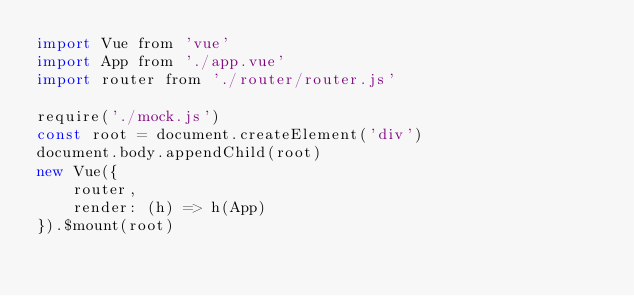<code> <loc_0><loc_0><loc_500><loc_500><_JavaScript_>import Vue from 'vue'
import App from './app.vue'
import router from './router/router.js'

require('./mock.js')
const root = document.createElement('div')
document.body.appendChild(root)
new Vue({
    router,
    render: (h) => h(App)
}).$mount(root)</code> 